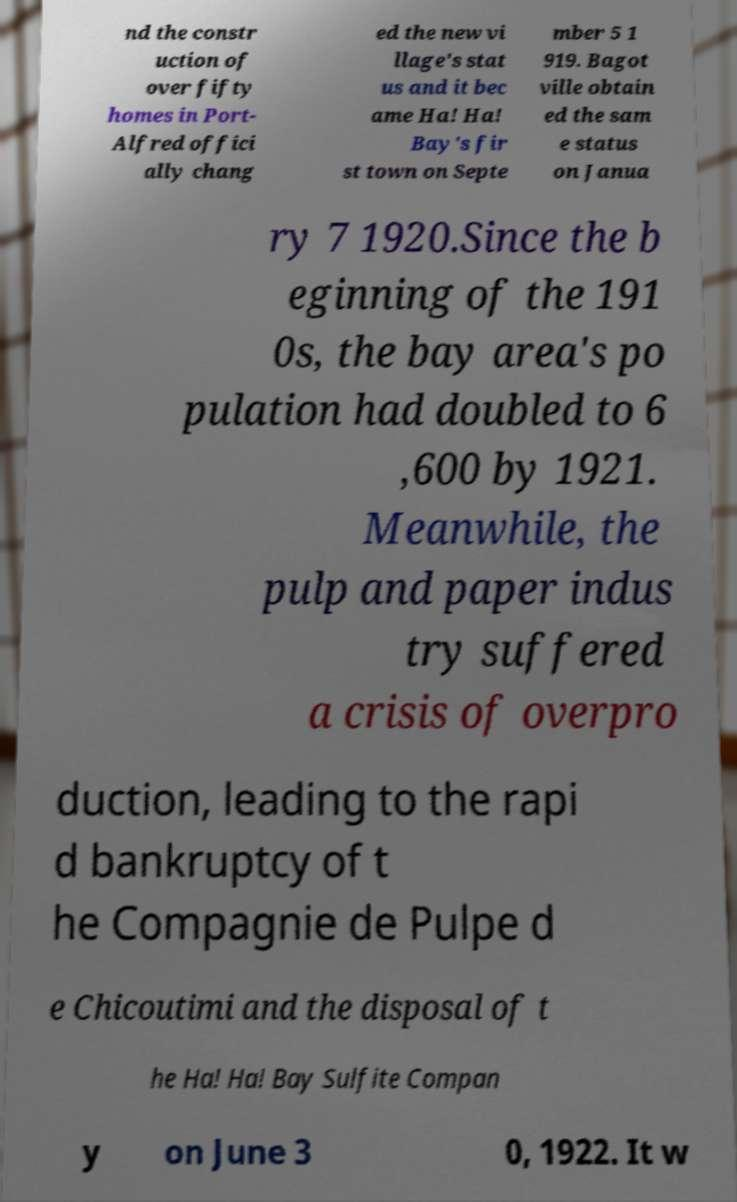There's text embedded in this image that I need extracted. Can you transcribe it verbatim? nd the constr uction of over fifty homes in Port- Alfred offici ally chang ed the new vi llage's stat us and it bec ame Ha! Ha! Bay's fir st town on Septe mber 5 1 919. Bagot ville obtain ed the sam e status on Janua ry 7 1920.Since the b eginning of the 191 0s, the bay area's po pulation had doubled to 6 ,600 by 1921. Meanwhile, the pulp and paper indus try suffered a crisis of overpro duction, leading to the rapi d bankruptcy of t he Compagnie de Pulpe d e Chicoutimi and the disposal of t he Ha! Ha! Bay Sulfite Compan y on June 3 0, 1922. It w 